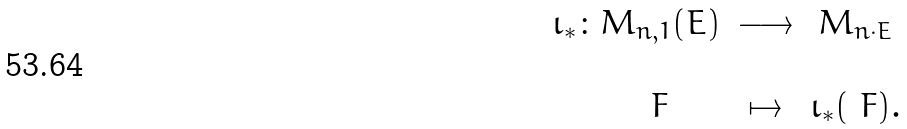<formula> <loc_0><loc_0><loc_500><loc_500>\begin{array} { c c c } \iota _ { * } \colon M _ { n , 1 } ( E ) & \longrightarrow & M _ { n \cdot E } \\ & & \\ \quad \ F & \mapsto & \iota _ { * } ( \ F ) . \end{array}</formula> 